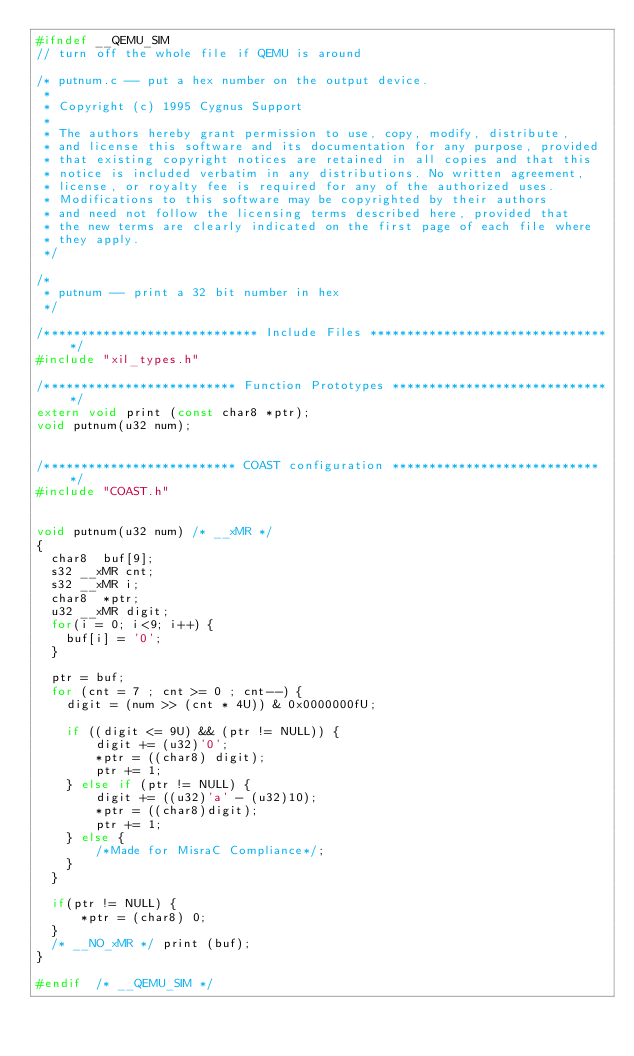Convert code to text. <code><loc_0><loc_0><loc_500><loc_500><_C_>#ifndef __QEMU_SIM
// turn off the whole file if QEMU is around

/* putnum.c -- put a hex number on the output device.
 *
 * Copyright (c) 1995 Cygnus Support
 *
 * The authors hereby grant permission to use, copy, modify, distribute,
 * and license this software and its documentation for any purpose, provided
 * that existing copyright notices are retained in all copies and that this
 * notice is included verbatim in any distributions. No written agreement,
 * license, or royalty fee is required for any of the authorized uses.
 * Modifications to this software may be copyrighted by their authors
 * and need not follow the licensing terms described here, provided that
 * the new terms are clearly indicated on the first page of each file where
 * they apply.
 */

/*
 * putnum -- print a 32 bit number in hex
 */

/***************************** Include Files *********************************/
#include "xil_types.h"

/************************** Function Prototypes ******************************/
extern void print (const char8 *ptr);
void putnum(u32 num);


/************************** COAST configuration *****************************/
#include "COAST.h"


void putnum(u32 num) /* __xMR */
{
  char8  buf[9];
  s32 __xMR cnt;
  s32 __xMR i;
  char8  *ptr;
  u32 __xMR digit;
  for(i = 0; i<9; i++) {
	buf[i] = '0';
  }

  ptr = buf;
  for (cnt = 7 ; cnt >= 0 ; cnt--) {
    digit = (num >> (cnt * 4U)) & 0x0000000fU;

    if ((digit <= 9U) && (ptr != NULL)) {
		digit += (u32)'0';
		*ptr = ((char8) digit);
		ptr += 1;
	} else if (ptr != NULL) {
		digit += ((u32)'a' - (u32)10);
		*ptr = ((char8)digit);
		ptr += 1;
	} else {
		/*Made for MisraC Compliance*/;
	}
  }

  if(ptr != NULL) {
	  *ptr = (char8) 0;
  }
  /* __NO_xMR */ print (buf);
}

#endif  /* __QEMU_SIM */

</code> 